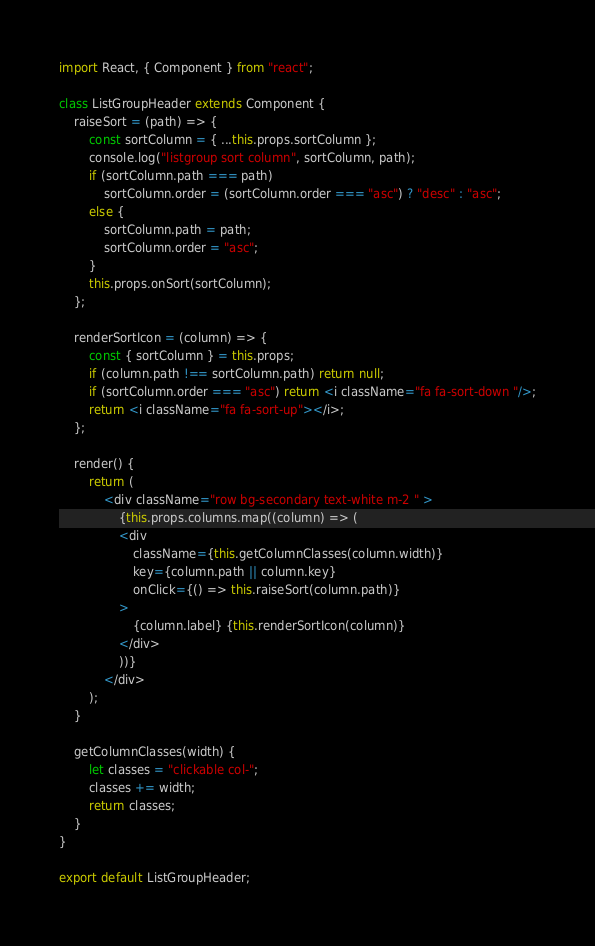Convert code to text. <code><loc_0><loc_0><loc_500><loc_500><_JavaScript_>import React, { Component } from "react";

class ListGroupHeader extends Component {
    raiseSort = (path) => {
        const sortColumn = { ...this.props.sortColumn };
        console.log("listgroup sort column", sortColumn, path);
        if (sortColumn.path === path)
            sortColumn.order = (sortColumn.order === "asc") ? "desc" : "asc";
        else {
            sortColumn.path = path;
            sortColumn.order = "asc";
        }
        this.props.onSort(sortColumn);
    };

    renderSortIcon = (column) => {
        const { sortColumn } = this.props;
        if (column.path !== sortColumn.path) return null;
        if (sortColumn.order === "asc") return <i className="fa fa-sort-down "/>;
        return <i className="fa fa-sort-up"></i>;    
    };

    render() {
        return (
            <div className="row bg-secondary text-white m-2 " >
                {this.props.columns.map((column) => (
                <div
                    className={this.getColumnClasses(column.width)}
                    key={column.path || column.key}
                    onClick={() => this.raiseSort(column.path)}
                >
                    {column.label} {this.renderSortIcon(column)}
                </div>
                ))}
            </div>
        );
    }

    getColumnClasses(width) {
        let classes = "clickable col-";
        classes += width;
        return classes;
    }
}

export default ListGroupHeader;</code> 